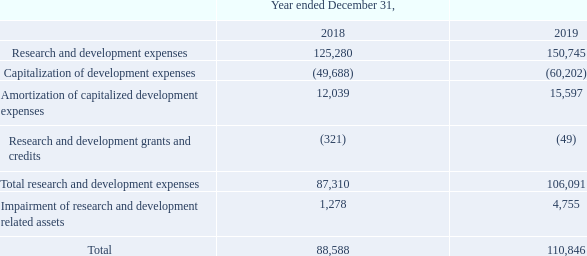NOTE 23. EXPENSES BY NATURE
Research and development consists of the following:
The impairment expenses in 2018 and 2019 are related to customer specific projects.
The Company’s operations in the Netherlands, Belgium and the United States receive research and development grants and credits from various sources.
Which countries that the company operates in receive research and development grants and credits? Netherlands, belgium, the united states. What are the years that information regarding Research and development is provided? 2018, 2019. What is the  Research and development expenses for 2018? 125,280. Which year had the higher total research and development expense? For row 9, col3 to 4 find the larger number and the corresponding year in row 2
Answer: 2019. What is the change in total Research and development expenses? 110,846-88,588
Answer: 22258. What is the percentage change in total Research and development expenses?
Answer scale should be: percent. (110,846-88,588)/88,588
Answer: 25.13. 